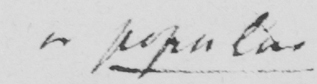What is written in this line of handwriting? or popular 